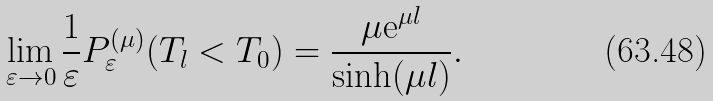<formula> <loc_0><loc_0><loc_500><loc_500>\lim _ { \varepsilon \rightarrow 0 } \frac { 1 } { \varepsilon } P ^ { ( \mu ) } _ { \varepsilon } ( T _ { l } < T _ { 0 } ) = \frac { \mu \mathrm e ^ { \mu l } } { \sinh ( \mu l ) } .</formula> 